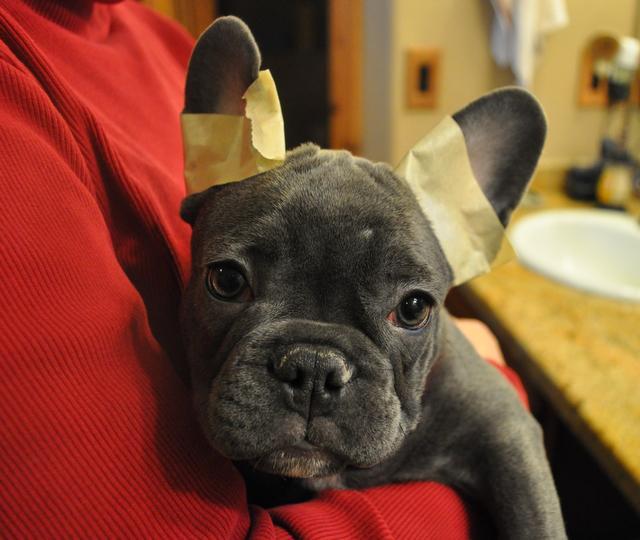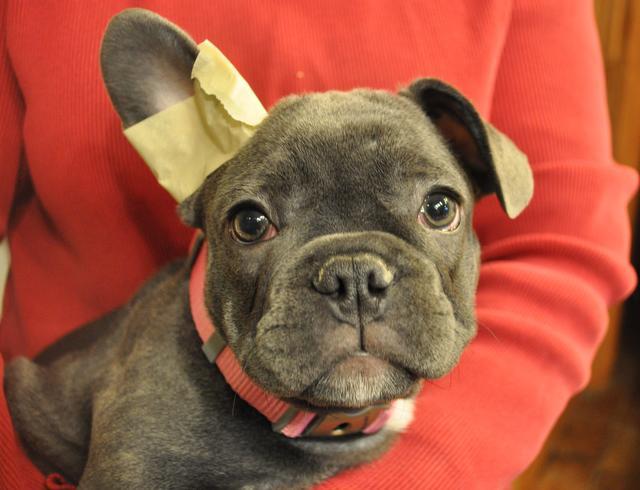The first image is the image on the left, the second image is the image on the right. Considering the images on both sides, is "At least one image shows a dark-furred dog with masking tape around at least one ear." valid? Answer yes or no. Yes. The first image is the image on the left, the second image is the image on the right. Considering the images on both sides, is "The dog in the left image has tape on its ears." valid? Answer yes or no. Yes. 